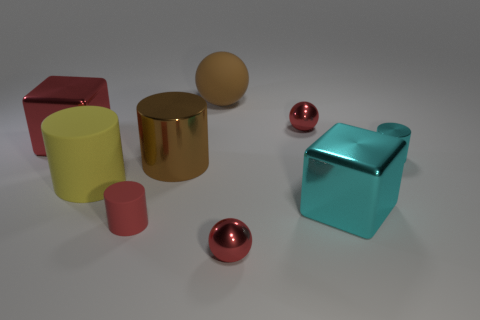How might the different colors in the image influence its interpretation? The use of primary colors, like the red and yellow, along with secondary colors, like the blue, creates a visually stimulating contrast. The colors and the sheen of the materials could lead viewers to perceive the objects as part of a modern art installation or as an exercise in color theory and visualization. 